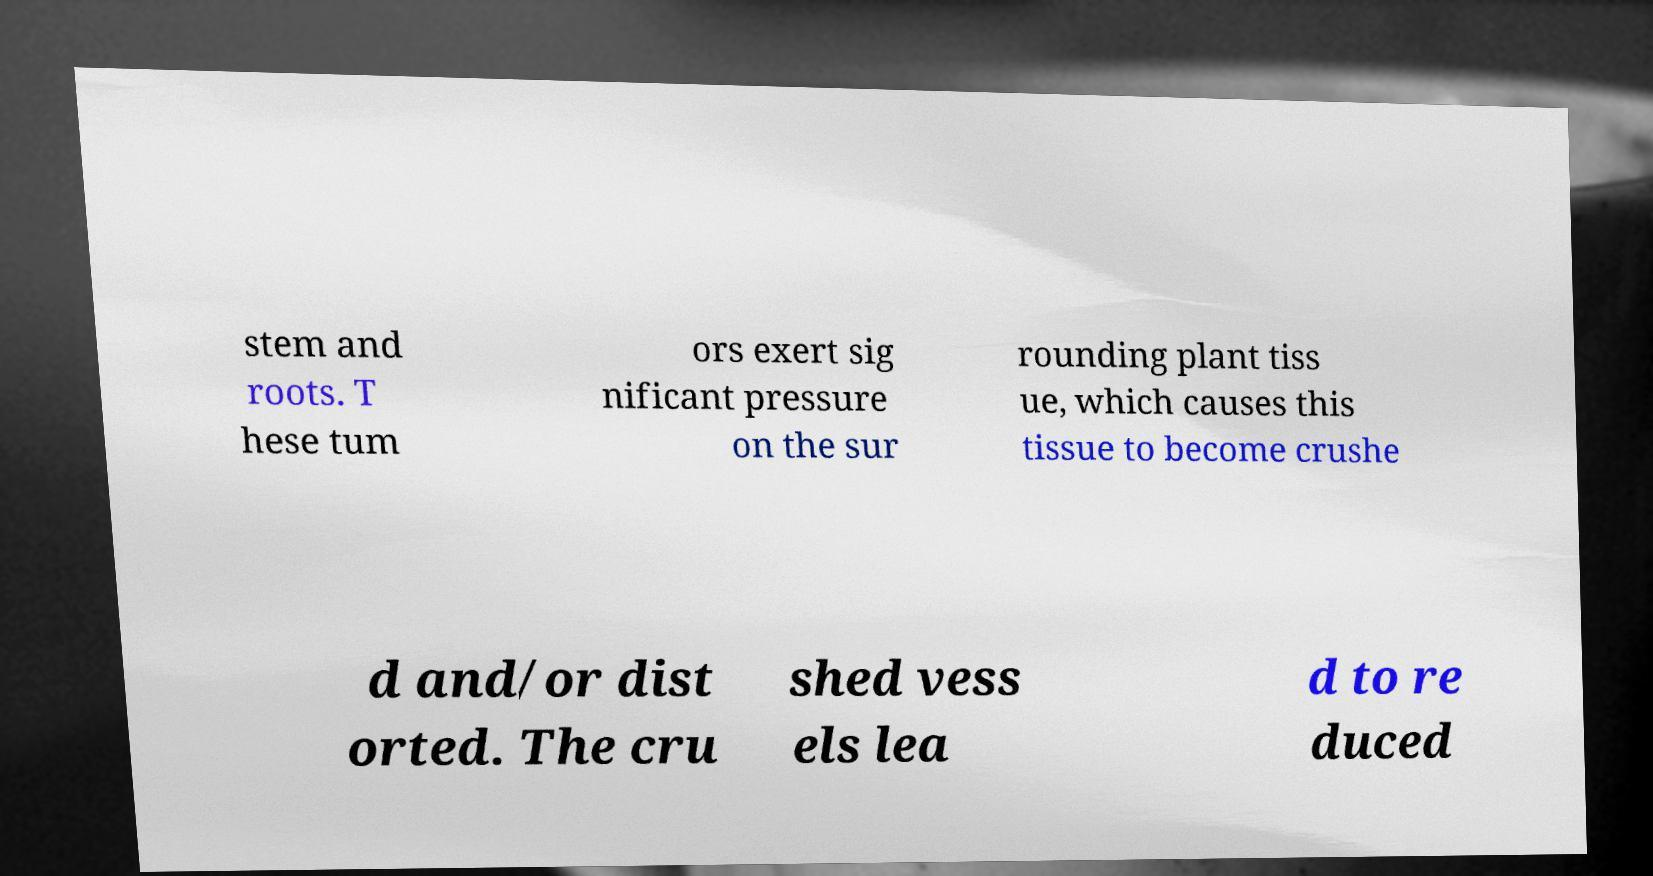Please read and relay the text visible in this image. What does it say? stem and roots. T hese tum ors exert sig nificant pressure on the sur rounding plant tiss ue, which causes this tissue to become crushe d and/or dist orted. The cru shed vess els lea d to re duced 